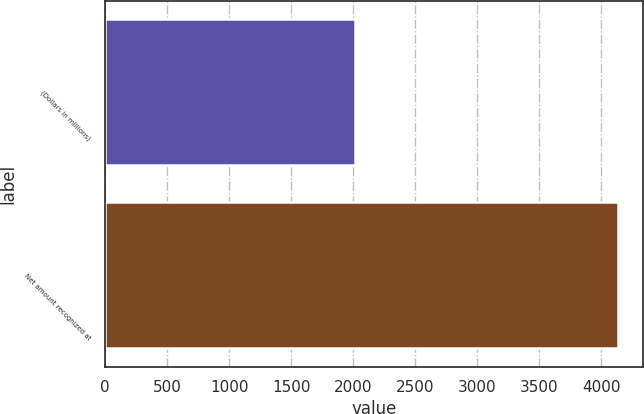<chart> <loc_0><loc_0><loc_500><loc_500><bar_chart><fcel>(Dollars in millions)<fcel>Net amount recognized at<nl><fcel>2013<fcel>4131<nl></chart> 